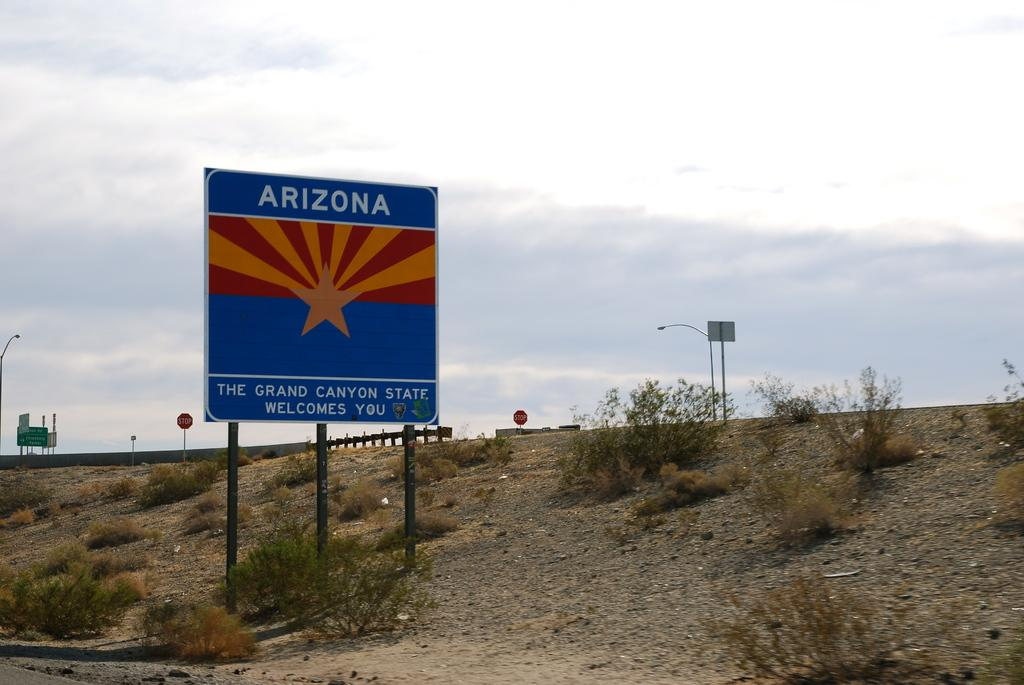<image>
Offer a succinct explanation of the picture presented. A large blue sign beside a highway says Arizona. 